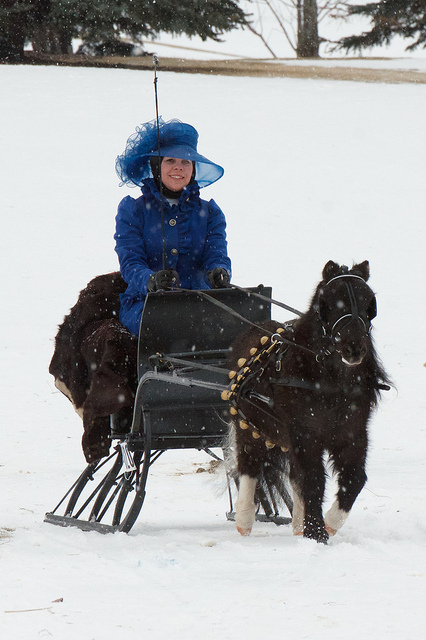How many dogs are playing in the ocean? 0 